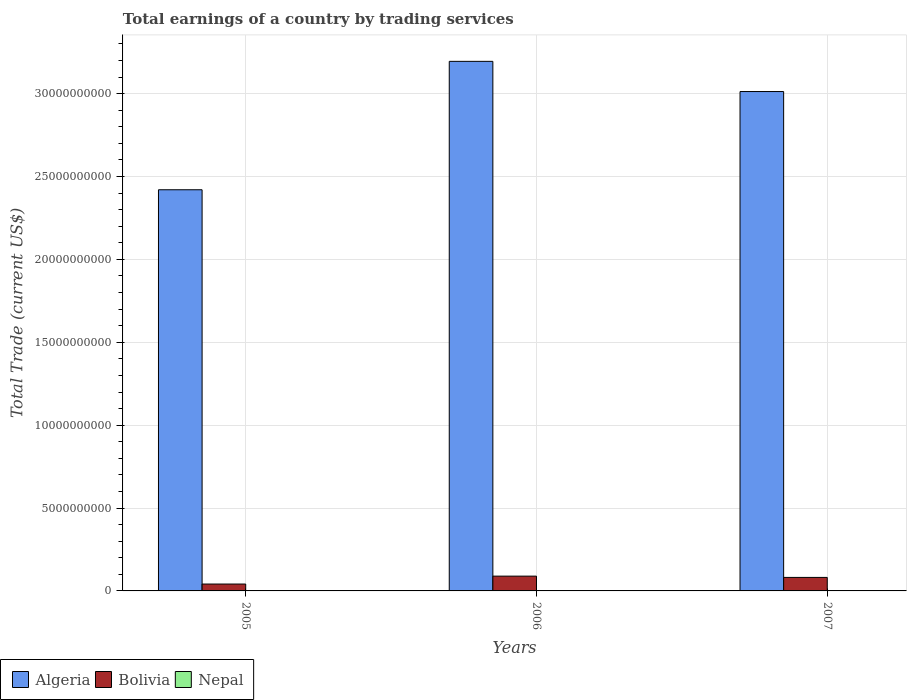How many different coloured bars are there?
Offer a very short reply. 2. How many groups of bars are there?
Keep it short and to the point. 3. Are the number of bars on each tick of the X-axis equal?
Your answer should be very brief. Yes. How many bars are there on the 2nd tick from the left?
Your response must be concise. 2. How many bars are there on the 3rd tick from the right?
Keep it short and to the point. 2. In how many cases, is the number of bars for a given year not equal to the number of legend labels?
Offer a terse response. 3. What is the total earnings in Bolivia in 2007?
Keep it short and to the point. 8.15e+08. Across all years, what is the maximum total earnings in Algeria?
Your response must be concise. 3.19e+1. Across all years, what is the minimum total earnings in Bolivia?
Make the answer very short. 4.15e+08. In which year was the total earnings in Bolivia maximum?
Offer a very short reply. 2006. What is the total total earnings in Algeria in the graph?
Your response must be concise. 8.63e+1. What is the difference between the total earnings in Bolivia in 2005 and that in 2007?
Your answer should be compact. -4.00e+08. What is the difference between the total earnings in Nepal in 2007 and the total earnings in Bolivia in 2005?
Your response must be concise. -4.15e+08. What is the average total earnings in Algeria per year?
Give a very brief answer. 2.88e+1. In the year 2006, what is the difference between the total earnings in Bolivia and total earnings in Algeria?
Offer a terse response. -3.11e+1. What is the ratio of the total earnings in Bolivia in 2005 to that in 2006?
Provide a succinct answer. 0.46. What is the difference between the highest and the second highest total earnings in Algeria?
Ensure brevity in your answer.  1.82e+09. What is the difference between the highest and the lowest total earnings in Bolivia?
Make the answer very short. 4.78e+08. In how many years, is the total earnings in Bolivia greater than the average total earnings in Bolivia taken over all years?
Your response must be concise. 2. Is the sum of the total earnings in Algeria in 2005 and 2006 greater than the maximum total earnings in Nepal across all years?
Provide a succinct answer. Yes. Is it the case that in every year, the sum of the total earnings in Nepal and total earnings in Algeria is greater than the total earnings in Bolivia?
Offer a terse response. Yes. How many years are there in the graph?
Make the answer very short. 3. What is the difference between two consecutive major ticks on the Y-axis?
Provide a succinct answer. 5.00e+09. How are the legend labels stacked?
Provide a short and direct response. Horizontal. What is the title of the graph?
Keep it short and to the point. Total earnings of a country by trading services. What is the label or title of the X-axis?
Your answer should be very brief. Years. What is the label or title of the Y-axis?
Offer a terse response. Total Trade (current US$). What is the Total Trade (current US$) of Algeria in 2005?
Your answer should be very brief. 2.42e+1. What is the Total Trade (current US$) of Bolivia in 2005?
Provide a succinct answer. 4.15e+08. What is the Total Trade (current US$) of Algeria in 2006?
Your response must be concise. 3.19e+1. What is the Total Trade (current US$) of Bolivia in 2006?
Your response must be concise. 8.92e+08. What is the Total Trade (current US$) in Algeria in 2007?
Provide a short and direct response. 3.01e+1. What is the Total Trade (current US$) in Bolivia in 2007?
Make the answer very short. 8.15e+08. Across all years, what is the maximum Total Trade (current US$) of Algeria?
Offer a terse response. 3.19e+1. Across all years, what is the maximum Total Trade (current US$) of Bolivia?
Provide a succinct answer. 8.92e+08. Across all years, what is the minimum Total Trade (current US$) of Algeria?
Your response must be concise. 2.42e+1. Across all years, what is the minimum Total Trade (current US$) in Bolivia?
Give a very brief answer. 4.15e+08. What is the total Total Trade (current US$) of Algeria in the graph?
Provide a succinct answer. 8.63e+1. What is the total Total Trade (current US$) of Bolivia in the graph?
Keep it short and to the point. 2.12e+09. What is the difference between the Total Trade (current US$) in Algeria in 2005 and that in 2006?
Offer a terse response. -7.75e+09. What is the difference between the Total Trade (current US$) of Bolivia in 2005 and that in 2006?
Offer a very short reply. -4.78e+08. What is the difference between the Total Trade (current US$) in Algeria in 2005 and that in 2007?
Provide a succinct answer. -5.92e+09. What is the difference between the Total Trade (current US$) in Bolivia in 2005 and that in 2007?
Your answer should be compact. -4.00e+08. What is the difference between the Total Trade (current US$) in Algeria in 2006 and that in 2007?
Offer a terse response. 1.82e+09. What is the difference between the Total Trade (current US$) of Bolivia in 2006 and that in 2007?
Your response must be concise. 7.79e+07. What is the difference between the Total Trade (current US$) of Algeria in 2005 and the Total Trade (current US$) of Bolivia in 2006?
Your answer should be very brief. 2.33e+1. What is the difference between the Total Trade (current US$) in Algeria in 2005 and the Total Trade (current US$) in Bolivia in 2007?
Your answer should be very brief. 2.34e+1. What is the difference between the Total Trade (current US$) of Algeria in 2006 and the Total Trade (current US$) of Bolivia in 2007?
Your answer should be compact. 3.11e+1. What is the average Total Trade (current US$) of Algeria per year?
Ensure brevity in your answer.  2.88e+1. What is the average Total Trade (current US$) in Bolivia per year?
Ensure brevity in your answer.  7.07e+08. What is the average Total Trade (current US$) of Nepal per year?
Provide a short and direct response. 0. In the year 2005, what is the difference between the Total Trade (current US$) in Algeria and Total Trade (current US$) in Bolivia?
Provide a short and direct response. 2.38e+1. In the year 2006, what is the difference between the Total Trade (current US$) of Algeria and Total Trade (current US$) of Bolivia?
Your answer should be compact. 3.11e+1. In the year 2007, what is the difference between the Total Trade (current US$) in Algeria and Total Trade (current US$) in Bolivia?
Offer a terse response. 2.93e+1. What is the ratio of the Total Trade (current US$) of Algeria in 2005 to that in 2006?
Provide a short and direct response. 0.76. What is the ratio of the Total Trade (current US$) in Bolivia in 2005 to that in 2006?
Your answer should be very brief. 0.46. What is the ratio of the Total Trade (current US$) of Algeria in 2005 to that in 2007?
Ensure brevity in your answer.  0.8. What is the ratio of the Total Trade (current US$) of Bolivia in 2005 to that in 2007?
Make the answer very short. 0.51. What is the ratio of the Total Trade (current US$) of Algeria in 2006 to that in 2007?
Offer a very short reply. 1.06. What is the ratio of the Total Trade (current US$) of Bolivia in 2006 to that in 2007?
Offer a terse response. 1.1. What is the difference between the highest and the second highest Total Trade (current US$) in Algeria?
Ensure brevity in your answer.  1.82e+09. What is the difference between the highest and the second highest Total Trade (current US$) in Bolivia?
Your response must be concise. 7.79e+07. What is the difference between the highest and the lowest Total Trade (current US$) in Algeria?
Your response must be concise. 7.75e+09. What is the difference between the highest and the lowest Total Trade (current US$) of Bolivia?
Ensure brevity in your answer.  4.78e+08. 